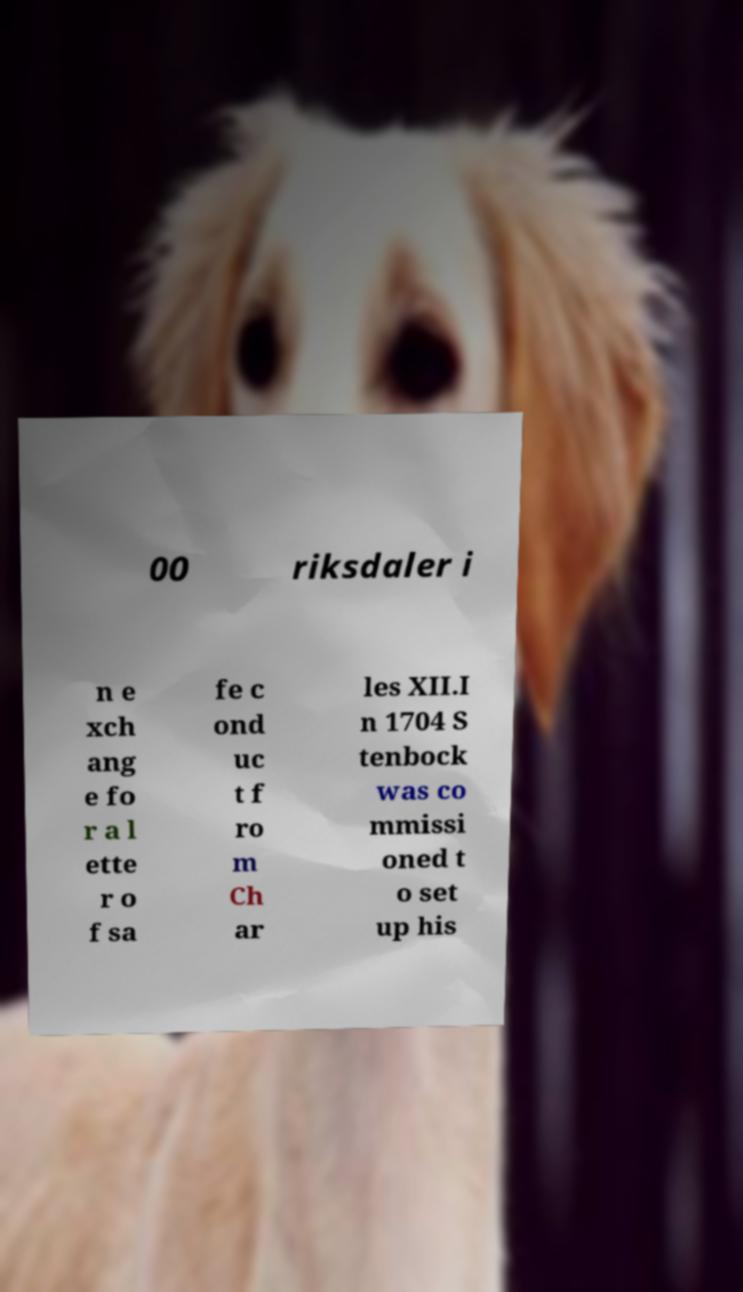I need the written content from this picture converted into text. Can you do that? 00 riksdaler i n e xch ang e fo r a l ette r o f sa fe c ond uc t f ro m Ch ar les XII.I n 1704 S tenbock was co mmissi oned t o set up his 